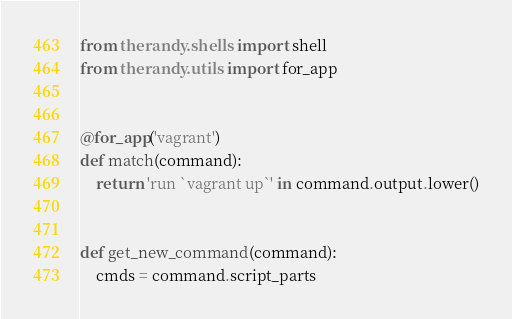Convert code to text. <code><loc_0><loc_0><loc_500><loc_500><_Python_>from therandy.shells import shell
from therandy.utils import for_app


@for_app('vagrant')
def match(command):
    return 'run `vagrant up`' in command.output.lower()


def get_new_command(command):
    cmds = command.script_parts</code> 